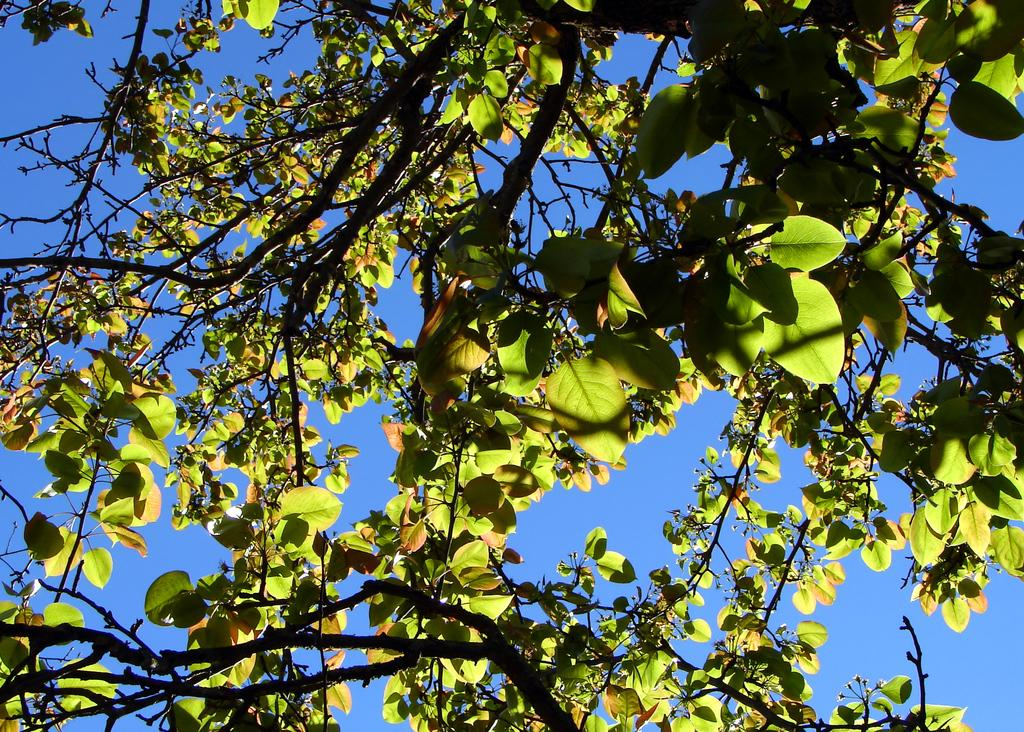What is the main object in the image? There is a tree in the image. What can be seen in the background of the image? The sky is visible in the image. How is the tree being affected by the environment in the image? Sunlight is falling on the tree. What decision does the ghost make in the image? There is no ghost present in the image, so no decision can be made by a ghost. 